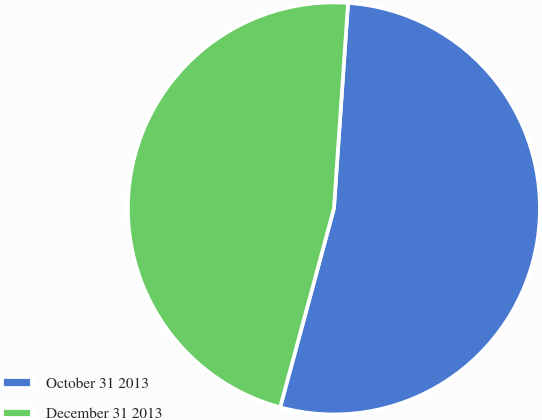Convert chart to OTSL. <chart><loc_0><loc_0><loc_500><loc_500><pie_chart><fcel>October 31 2013<fcel>December 31 2013<nl><fcel>53.11%<fcel>46.89%<nl></chart> 